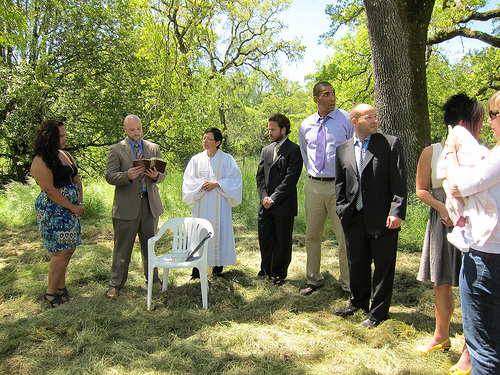<image>
Can you confirm if the tree is in front of the man? No. The tree is not in front of the man. The spatial positioning shows a different relationship between these objects. 